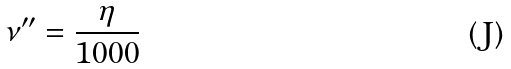Convert formula to latex. <formula><loc_0><loc_0><loc_500><loc_500>\nu ^ { \prime \prime } = \frac { \eta } { 1 0 0 0 }</formula> 